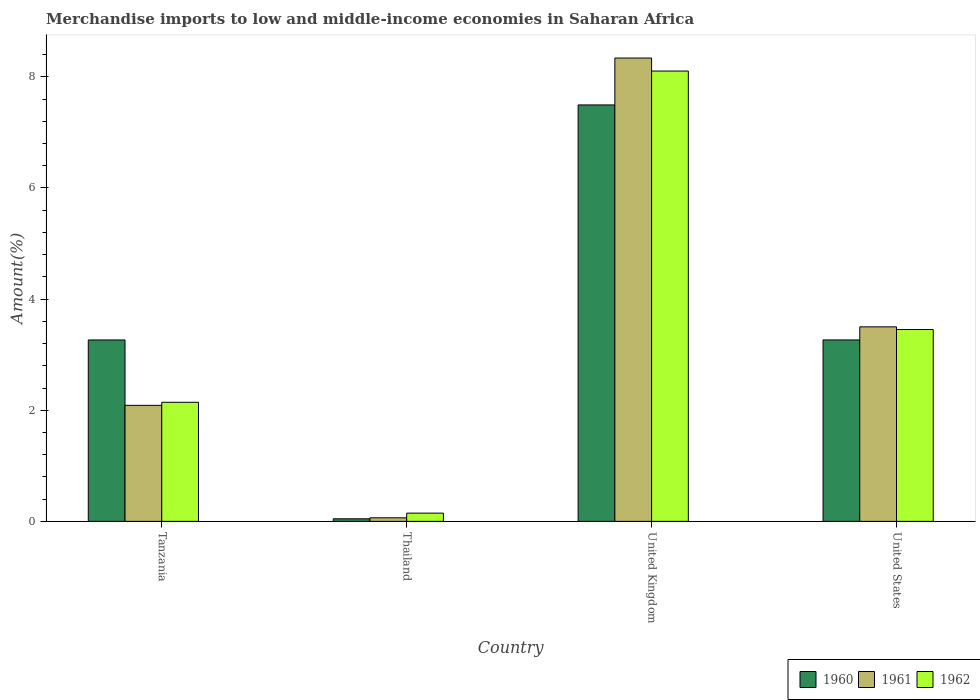How many different coloured bars are there?
Provide a short and direct response. 3. How many groups of bars are there?
Make the answer very short. 4. Are the number of bars per tick equal to the number of legend labels?
Provide a short and direct response. Yes. Are the number of bars on each tick of the X-axis equal?
Keep it short and to the point. Yes. What is the label of the 1st group of bars from the left?
Offer a terse response. Tanzania. What is the percentage of amount earned from merchandise imports in 1961 in United States?
Make the answer very short. 3.5. Across all countries, what is the maximum percentage of amount earned from merchandise imports in 1960?
Make the answer very short. 7.49. Across all countries, what is the minimum percentage of amount earned from merchandise imports in 1960?
Provide a short and direct response. 0.05. In which country was the percentage of amount earned from merchandise imports in 1960 minimum?
Give a very brief answer. Thailand. What is the total percentage of amount earned from merchandise imports in 1961 in the graph?
Make the answer very short. 13.99. What is the difference between the percentage of amount earned from merchandise imports in 1960 in Tanzania and that in United Kingdom?
Provide a short and direct response. -4.23. What is the difference between the percentage of amount earned from merchandise imports in 1962 in Thailand and the percentage of amount earned from merchandise imports in 1960 in United States?
Provide a short and direct response. -3.12. What is the average percentage of amount earned from merchandise imports in 1960 per country?
Keep it short and to the point. 3.52. What is the difference between the percentage of amount earned from merchandise imports of/in 1960 and percentage of amount earned from merchandise imports of/in 1961 in Tanzania?
Provide a succinct answer. 1.18. What is the ratio of the percentage of amount earned from merchandise imports in 1962 in Tanzania to that in United Kingdom?
Ensure brevity in your answer.  0.26. Is the percentage of amount earned from merchandise imports in 1961 in Tanzania less than that in United Kingdom?
Your response must be concise. Yes. What is the difference between the highest and the second highest percentage of amount earned from merchandise imports in 1961?
Give a very brief answer. 6.25. What is the difference between the highest and the lowest percentage of amount earned from merchandise imports in 1960?
Your answer should be compact. 7.45. In how many countries, is the percentage of amount earned from merchandise imports in 1962 greater than the average percentage of amount earned from merchandise imports in 1962 taken over all countries?
Provide a succinct answer. 1. What does the 1st bar from the right in United States represents?
Your response must be concise. 1962. Is it the case that in every country, the sum of the percentage of amount earned from merchandise imports in 1960 and percentage of amount earned from merchandise imports in 1962 is greater than the percentage of amount earned from merchandise imports in 1961?
Your response must be concise. Yes. How many bars are there?
Your response must be concise. 12. Are all the bars in the graph horizontal?
Make the answer very short. No. How many countries are there in the graph?
Your answer should be compact. 4. What is the difference between two consecutive major ticks on the Y-axis?
Provide a short and direct response. 2. Are the values on the major ticks of Y-axis written in scientific E-notation?
Provide a succinct answer. No. How are the legend labels stacked?
Offer a terse response. Horizontal. What is the title of the graph?
Your answer should be compact. Merchandise imports to low and middle-income economies in Saharan Africa. What is the label or title of the Y-axis?
Keep it short and to the point. Amount(%). What is the Amount(%) of 1960 in Tanzania?
Provide a succinct answer. 3.26. What is the Amount(%) in 1961 in Tanzania?
Keep it short and to the point. 2.09. What is the Amount(%) of 1962 in Tanzania?
Offer a terse response. 2.14. What is the Amount(%) of 1960 in Thailand?
Offer a very short reply. 0.05. What is the Amount(%) in 1961 in Thailand?
Ensure brevity in your answer.  0.06. What is the Amount(%) of 1962 in Thailand?
Offer a terse response. 0.15. What is the Amount(%) of 1960 in United Kingdom?
Offer a very short reply. 7.49. What is the Amount(%) of 1961 in United Kingdom?
Ensure brevity in your answer.  8.34. What is the Amount(%) of 1962 in United Kingdom?
Provide a succinct answer. 8.1. What is the Amount(%) of 1960 in United States?
Give a very brief answer. 3.27. What is the Amount(%) of 1961 in United States?
Offer a very short reply. 3.5. What is the Amount(%) of 1962 in United States?
Your answer should be very brief. 3.45. Across all countries, what is the maximum Amount(%) of 1960?
Make the answer very short. 7.49. Across all countries, what is the maximum Amount(%) in 1961?
Give a very brief answer. 8.34. Across all countries, what is the maximum Amount(%) of 1962?
Offer a terse response. 8.1. Across all countries, what is the minimum Amount(%) in 1960?
Keep it short and to the point. 0.05. Across all countries, what is the minimum Amount(%) in 1961?
Ensure brevity in your answer.  0.06. Across all countries, what is the minimum Amount(%) of 1962?
Give a very brief answer. 0.15. What is the total Amount(%) of 1960 in the graph?
Provide a succinct answer. 14.07. What is the total Amount(%) in 1961 in the graph?
Make the answer very short. 13.99. What is the total Amount(%) of 1962 in the graph?
Offer a terse response. 13.85. What is the difference between the Amount(%) of 1960 in Tanzania and that in Thailand?
Provide a short and direct response. 3.22. What is the difference between the Amount(%) of 1961 in Tanzania and that in Thailand?
Keep it short and to the point. 2.02. What is the difference between the Amount(%) in 1962 in Tanzania and that in Thailand?
Give a very brief answer. 1.99. What is the difference between the Amount(%) of 1960 in Tanzania and that in United Kingdom?
Your response must be concise. -4.23. What is the difference between the Amount(%) in 1961 in Tanzania and that in United Kingdom?
Ensure brevity in your answer.  -6.25. What is the difference between the Amount(%) in 1962 in Tanzania and that in United Kingdom?
Offer a terse response. -5.96. What is the difference between the Amount(%) of 1960 in Tanzania and that in United States?
Ensure brevity in your answer.  -0. What is the difference between the Amount(%) of 1961 in Tanzania and that in United States?
Your answer should be compact. -1.41. What is the difference between the Amount(%) in 1962 in Tanzania and that in United States?
Give a very brief answer. -1.31. What is the difference between the Amount(%) in 1960 in Thailand and that in United Kingdom?
Give a very brief answer. -7.45. What is the difference between the Amount(%) in 1961 in Thailand and that in United Kingdom?
Offer a very short reply. -8.27. What is the difference between the Amount(%) of 1962 in Thailand and that in United Kingdom?
Provide a short and direct response. -7.96. What is the difference between the Amount(%) in 1960 in Thailand and that in United States?
Your response must be concise. -3.22. What is the difference between the Amount(%) of 1961 in Thailand and that in United States?
Keep it short and to the point. -3.44. What is the difference between the Amount(%) of 1962 in Thailand and that in United States?
Offer a terse response. -3.3. What is the difference between the Amount(%) of 1960 in United Kingdom and that in United States?
Provide a short and direct response. 4.23. What is the difference between the Amount(%) of 1961 in United Kingdom and that in United States?
Provide a succinct answer. 4.84. What is the difference between the Amount(%) in 1962 in United Kingdom and that in United States?
Your response must be concise. 4.65. What is the difference between the Amount(%) of 1960 in Tanzania and the Amount(%) of 1961 in Thailand?
Your response must be concise. 3.2. What is the difference between the Amount(%) of 1960 in Tanzania and the Amount(%) of 1962 in Thailand?
Offer a very short reply. 3.12. What is the difference between the Amount(%) in 1961 in Tanzania and the Amount(%) in 1962 in Thailand?
Offer a terse response. 1.94. What is the difference between the Amount(%) in 1960 in Tanzania and the Amount(%) in 1961 in United Kingdom?
Offer a very short reply. -5.07. What is the difference between the Amount(%) in 1960 in Tanzania and the Amount(%) in 1962 in United Kingdom?
Make the answer very short. -4.84. What is the difference between the Amount(%) of 1961 in Tanzania and the Amount(%) of 1962 in United Kingdom?
Ensure brevity in your answer.  -6.02. What is the difference between the Amount(%) of 1960 in Tanzania and the Amount(%) of 1961 in United States?
Your answer should be very brief. -0.24. What is the difference between the Amount(%) in 1960 in Tanzania and the Amount(%) in 1962 in United States?
Your answer should be compact. -0.19. What is the difference between the Amount(%) of 1961 in Tanzania and the Amount(%) of 1962 in United States?
Ensure brevity in your answer.  -1.36. What is the difference between the Amount(%) of 1960 in Thailand and the Amount(%) of 1961 in United Kingdom?
Offer a terse response. -8.29. What is the difference between the Amount(%) of 1960 in Thailand and the Amount(%) of 1962 in United Kingdom?
Provide a succinct answer. -8.06. What is the difference between the Amount(%) of 1961 in Thailand and the Amount(%) of 1962 in United Kingdom?
Ensure brevity in your answer.  -8.04. What is the difference between the Amount(%) of 1960 in Thailand and the Amount(%) of 1961 in United States?
Provide a short and direct response. -3.45. What is the difference between the Amount(%) of 1960 in Thailand and the Amount(%) of 1962 in United States?
Offer a very short reply. -3.41. What is the difference between the Amount(%) of 1961 in Thailand and the Amount(%) of 1962 in United States?
Provide a short and direct response. -3.39. What is the difference between the Amount(%) in 1960 in United Kingdom and the Amount(%) in 1961 in United States?
Give a very brief answer. 3.99. What is the difference between the Amount(%) in 1960 in United Kingdom and the Amount(%) in 1962 in United States?
Your answer should be very brief. 4.04. What is the difference between the Amount(%) in 1961 in United Kingdom and the Amount(%) in 1962 in United States?
Provide a short and direct response. 4.89. What is the average Amount(%) of 1960 per country?
Your response must be concise. 3.52. What is the average Amount(%) in 1961 per country?
Your response must be concise. 3.5. What is the average Amount(%) in 1962 per country?
Offer a very short reply. 3.46. What is the difference between the Amount(%) in 1960 and Amount(%) in 1961 in Tanzania?
Your answer should be very brief. 1.18. What is the difference between the Amount(%) in 1960 and Amount(%) in 1962 in Tanzania?
Provide a succinct answer. 1.12. What is the difference between the Amount(%) of 1961 and Amount(%) of 1962 in Tanzania?
Your response must be concise. -0.05. What is the difference between the Amount(%) in 1960 and Amount(%) in 1961 in Thailand?
Keep it short and to the point. -0.02. What is the difference between the Amount(%) in 1960 and Amount(%) in 1962 in Thailand?
Your answer should be very brief. -0.1. What is the difference between the Amount(%) in 1961 and Amount(%) in 1962 in Thailand?
Provide a short and direct response. -0.08. What is the difference between the Amount(%) in 1960 and Amount(%) in 1961 in United Kingdom?
Offer a very short reply. -0.84. What is the difference between the Amount(%) of 1960 and Amount(%) of 1962 in United Kingdom?
Your answer should be very brief. -0.61. What is the difference between the Amount(%) in 1961 and Amount(%) in 1962 in United Kingdom?
Keep it short and to the point. 0.23. What is the difference between the Amount(%) in 1960 and Amount(%) in 1961 in United States?
Offer a very short reply. -0.24. What is the difference between the Amount(%) in 1960 and Amount(%) in 1962 in United States?
Make the answer very short. -0.19. What is the difference between the Amount(%) in 1961 and Amount(%) in 1962 in United States?
Ensure brevity in your answer.  0.05. What is the ratio of the Amount(%) of 1960 in Tanzania to that in Thailand?
Give a very brief answer. 70.85. What is the ratio of the Amount(%) of 1961 in Tanzania to that in Thailand?
Keep it short and to the point. 32.6. What is the ratio of the Amount(%) in 1962 in Tanzania to that in Thailand?
Offer a terse response. 14.47. What is the ratio of the Amount(%) in 1960 in Tanzania to that in United Kingdom?
Your response must be concise. 0.44. What is the ratio of the Amount(%) of 1961 in Tanzania to that in United Kingdom?
Provide a short and direct response. 0.25. What is the ratio of the Amount(%) of 1962 in Tanzania to that in United Kingdom?
Offer a terse response. 0.26. What is the ratio of the Amount(%) of 1960 in Tanzania to that in United States?
Offer a very short reply. 1. What is the ratio of the Amount(%) in 1961 in Tanzania to that in United States?
Provide a succinct answer. 0.6. What is the ratio of the Amount(%) in 1962 in Tanzania to that in United States?
Make the answer very short. 0.62. What is the ratio of the Amount(%) of 1960 in Thailand to that in United Kingdom?
Offer a terse response. 0.01. What is the ratio of the Amount(%) of 1961 in Thailand to that in United Kingdom?
Offer a terse response. 0.01. What is the ratio of the Amount(%) of 1962 in Thailand to that in United Kingdom?
Your answer should be compact. 0.02. What is the ratio of the Amount(%) of 1960 in Thailand to that in United States?
Provide a succinct answer. 0.01. What is the ratio of the Amount(%) of 1961 in Thailand to that in United States?
Offer a terse response. 0.02. What is the ratio of the Amount(%) in 1962 in Thailand to that in United States?
Give a very brief answer. 0.04. What is the ratio of the Amount(%) in 1960 in United Kingdom to that in United States?
Offer a very short reply. 2.3. What is the ratio of the Amount(%) of 1961 in United Kingdom to that in United States?
Your response must be concise. 2.38. What is the ratio of the Amount(%) in 1962 in United Kingdom to that in United States?
Offer a very short reply. 2.35. What is the difference between the highest and the second highest Amount(%) of 1960?
Your answer should be very brief. 4.23. What is the difference between the highest and the second highest Amount(%) in 1961?
Your answer should be compact. 4.84. What is the difference between the highest and the second highest Amount(%) of 1962?
Keep it short and to the point. 4.65. What is the difference between the highest and the lowest Amount(%) in 1960?
Provide a succinct answer. 7.45. What is the difference between the highest and the lowest Amount(%) of 1961?
Offer a terse response. 8.27. What is the difference between the highest and the lowest Amount(%) in 1962?
Provide a short and direct response. 7.96. 